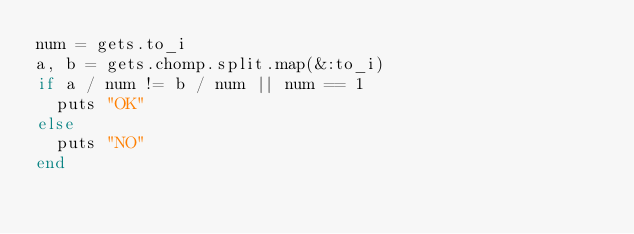Convert code to text. <code><loc_0><loc_0><loc_500><loc_500><_Ruby_>num = gets.to_i
a, b = gets.chomp.split.map(&:to_i)
if a / num != b / num || num == 1
  puts "OK"
else
  puts "NO"
end</code> 